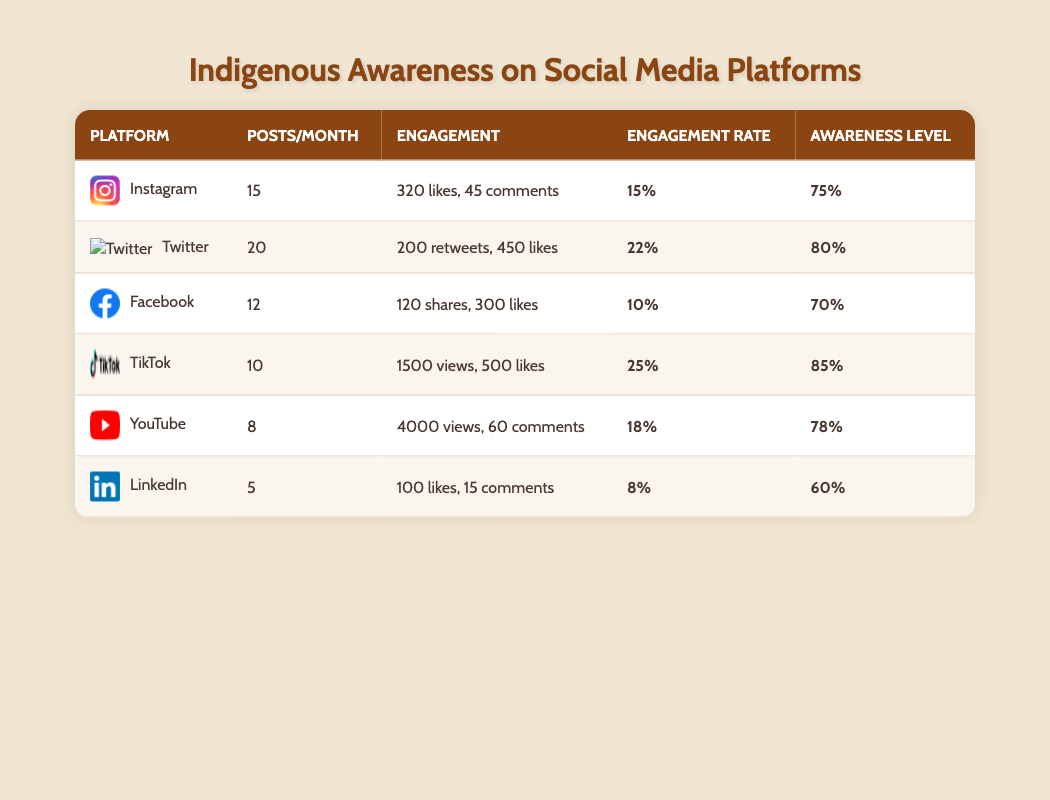What is the engagement rate for TikTok? The engagement rate can be found in the engagement rate column for TikTok, which is 25.
Answer: 25 Which platform has the highest awareness level? By comparing the awareness level values in the table, TikTok has the highest awareness level at 85.
Answer: TikTok What is the difference in posts per month between Instagram and LinkedIn? Instagram has 15 posts per month while LinkedIn has 5 posts per month. The difference is calculated as 15 - 5 = 10.
Answer: 10 Is the average number of likes on YouTube greater than on Facebook? YouTube has an average of 4000 views with 60 comments, whereas Facebook has 300 likes. Since we are comparing likes, yes, YouTube has significantly more engagement; however, since there are more views on YouTube, the aspect of likes can influence this comparison. We can only focus strictly on likes for the answer. The answer is yes, Facebook has fewer likes at 300 compared to 4000 views on YouTube but let’s keep in mind the nature of engagement rates versus total likes comparison.
Answer: No What is the average awareness level across all platforms? To find the average awareness level, we sum the awareness levels: 75 + 80 + 70 + 85 + 78 + 60 = 448, then divide by the number of platforms (6): 448/6 = 74.67. This rounds up to an average of approximately 75.
Answer: 75 Which platform has the lowest engagement rate? By checking the engagement rate column, we find LinkedIn has the lowest engagement rate at 8.
Answer: LinkedIn How many more likes does Twitter have than Instagram? Twitter has an average of 450 likes while Instagram has 320 likes. The difference is calculated as 450 - 320 = 130.
Answer: 130 What percentage engagement rate does Facebook have compared to TikTok? Facebook’s engagement rate is 10, while TikTok's engagement rate is 25. To find the percentage comparison, we can calculate (10/25)*100 which equals 40%, indicating that Facebook's engagement rate is 40% of TikTok's.
Answer: 40 Is the average number of posts per month greater for Facebook compared to Instagram? Facebook has 12 posts per month and Instagram has 15 posts per month, so we check if 12 is greater than 15, and it is not.
Answer: No 